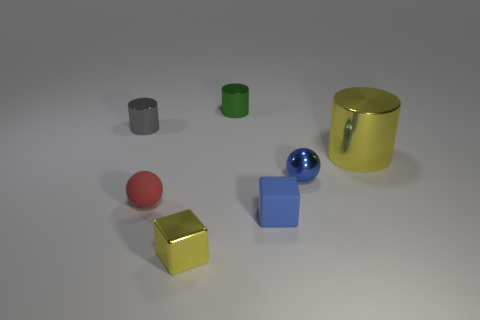Add 1 tiny matte blocks. How many objects exist? 8 Subtract all cubes. How many objects are left? 5 Add 4 cubes. How many cubes are left? 6 Add 1 gray cylinders. How many gray cylinders exist? 2 Subtract 1 blue blocks. How many objects are left? 6 Subtract all yellow blocks. Subtract all metallic cubes. How many objects are left? 5 